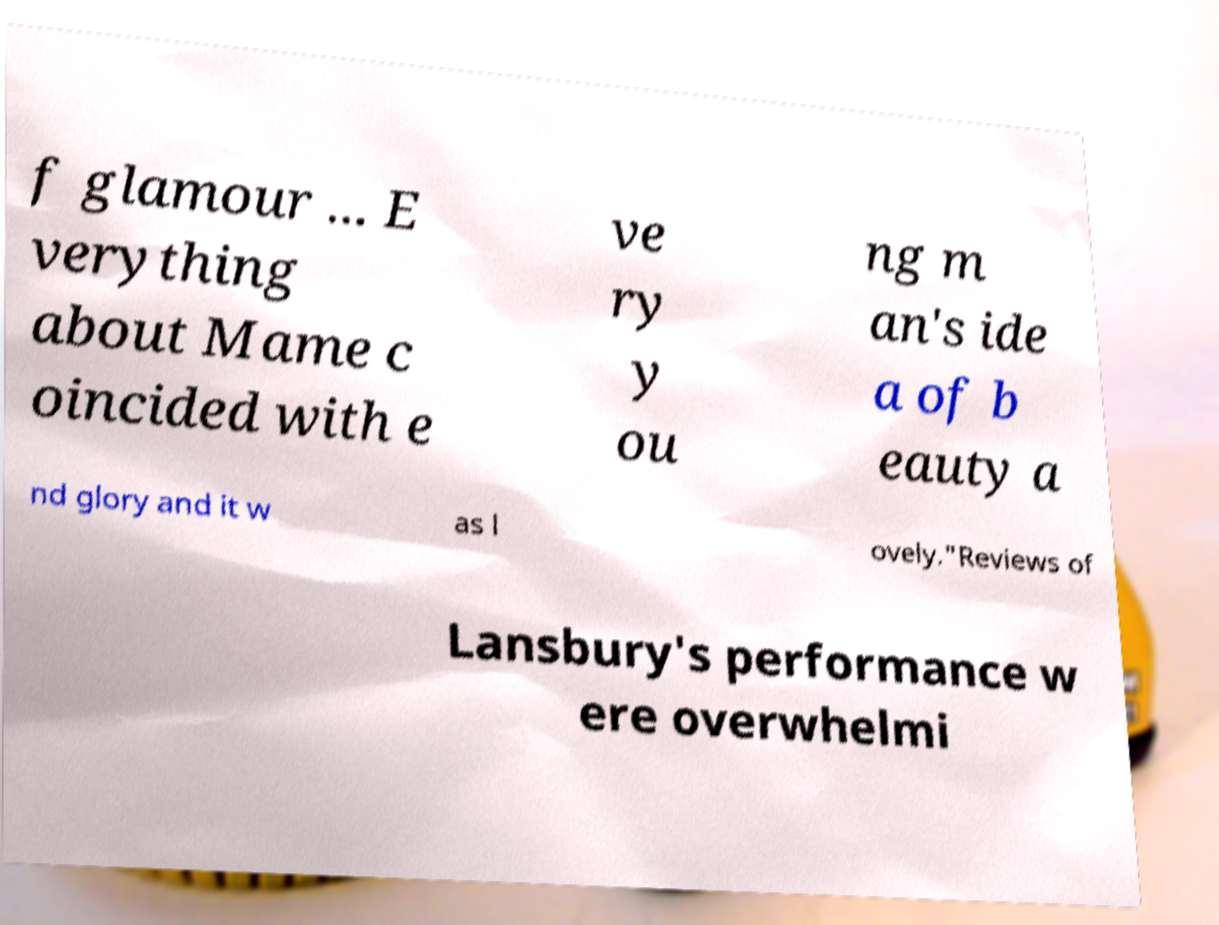Can you read and provide the text displayed in the image?This photo seems to have some interesting text. Can you extract and type it out for me? f glamour ... E verything about Mame c oincided with e ve ry y ou ng m an's ide a of b eauty a nd glory and it w as l ovely."Reviews of Lansbury's performance w ere overwhelmi 